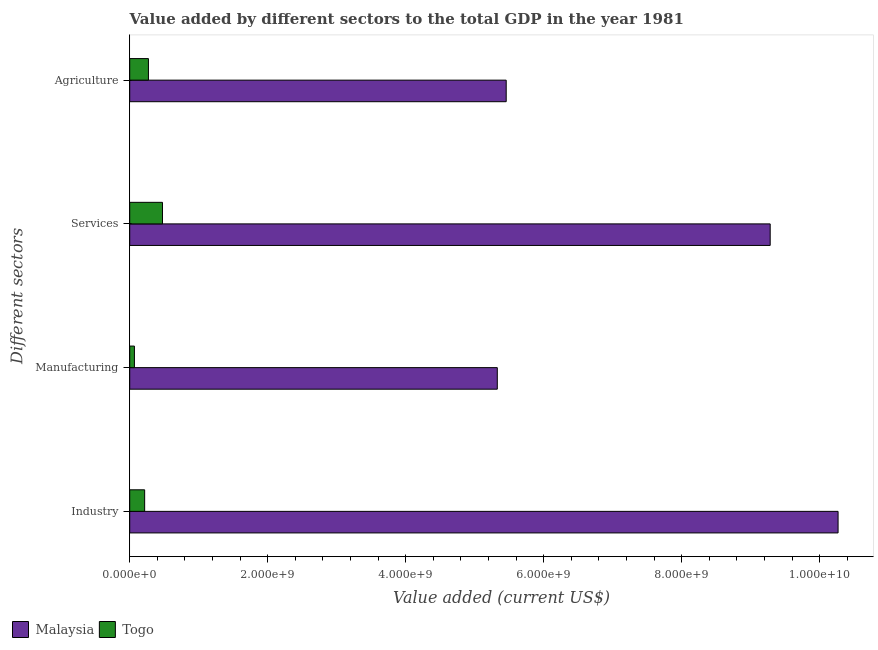How many groups of bars are there?
Give a very brief answer. 4. Are the number of bars on each tick of the Y-axis equal?
Offer a very short reply. Yes. How many bars are there on the 3rd tick from the top?
Your answer should be very brief. 2. How many bars are there on the 2nd tick from the bottom?
Offer a terse response. 2. What is the label of the 2nd group of bars from the top?
Ensure brevity in your answer.  Services. What is the value added by industrial sector in Togo?
Give a very brief answer. 2.16e+08. Across all countries, what is the maximum value added by services sector?
Ensure brevity in your answer.  9.28e+09. Across all countries, what is the minimum value added by industrial sector?
Ensure brevity in your answer.  2.16e+08. In which country was the value added by industrial sector maximum?
Give a very brief answer. Malaysia. In which country was the value added by industrial sector minimum?
Ensure brevity in your answer.  Togo. What is the total value added by services sector in the graph?
Offer a very short reply. 9.76e+09. What is the difference between the value added by manufacturing sector in Togo and that in Malaysia?
Provide a short and direct response. -5.26e+09. What is the difference between the value added by services sector in Malaysia and the value added by industrial sector in Togo?
Give a very brief answer. 9.07e+09. What is the average value added by agricultural sector per country?
Your answer should be very brief. 2.86e+09. What is the difference between the value added by agricultural sector and value added by industrial sector in Togo?
Provide a short and direct response. 5.48e+07. What is the ratio of the value added by industrial sector in Malaysia to that in Togo?
Keep it short and to the point. 47.44. What is the difference between the highest and the second highest value added by agricultural sector?
Give a very brief answer. 5.19e+09. What is the difference between the highest and the lowest value added by industrial sector?
Make the answer very short. 1.00e+1. In how many countries, is the value added by agricultural sector greater than the average value added by agricultural sector taken over all countries?
Your answer should be compact. 1. Is the sum of the value added by services sector in Togo and Malaysia greater than the maximum value added by industrial sector across all countries?
Your response must be concise. No. What does the 1st bar from the top in Manufacturing represents?
Your answer should be compact. Togo. What does the 1st bar from the bottom in Services represents?
Keep it short and to the point. Malaysia. How many countries are there in the graph?
Offer a terse response. 2. What is the difference between two consecutive major ticks on the X-axis?
Your answer should be compact. 2.00e+09. Does the graph contain any zero values?
Your response must be concise. No. Where does the legend appear in the graph?
Provide a short and direct response. Bottom left. How are the legend labels stacked?
Offer a terse response. Horizontal. What is the title of the graph?
Provide a succinct answer. Value added by different sectors to the total GDP in the year 1981. What is the label or title of the X-axis?
Make the answer very short. Value added (current US$). What is the label or title of the Y-axis?
Ensure brevity in your answer.  Different sectors. What is the Value added (current US$) of Malaysia in Industry?
Offer a very short reply. 1.03e+1. What is the Value added (current US$) of Togo in Industry?
Your response must be concise. 2.16e+08. What is the Value added (current US$) in Malaysia in Manufacturing?
Provide a short and direct response. 5.33e+09. What is the Value added (current US$) in Togo in Manufacturing?
Your answer should be very brief. 6.81e+07. What is the Value added (current US$) in Malaysia in Services?
Make the answer very short. 9.28e+09. What is the Value added (current US$) in Togo in Services?
Offer a terse response. 4.75e+08. What is the Value added (current US$) of Malaysia in Agriculture?
Make the answer very short. 5.46e+09. What is the Value added (current US$) in Togo in Agriculture?
Ensure brevity in your answer.  2.71e+08. Across all Different sectors, what is the maximum Value added (current US$) in Malaysia?
Give a very brief answer. 1.03e+1. Across all Different sectors, what is the maximum Value added (current US$) in Togo?
Provide a short and direct response. 4.75e+08. Across all Different sectors, what is the minimum Value added (current US$) in Malaysia?
Keep it short and to the point. 5.33e+09. Across all Different sectors, what is the minimum Value added (current US$) in Togo?
Offer a terse response. 6.81e+07. What is the total Value added (current US$) of Malaysia in the graph?
Offer a very short reply. 3.03e+1. What is the total Value added (current US$) in Togo in the graph?
Your answer should be compact. 1.03e+09. What is the difference between the Value added (current US$) in Malaysia in Industry and that in Manufacturing?
Make the answer very short. 4.94e+09. What is the difference between the Value added (current US$) of Togo in Industry and that in Manufacturing?
Provide a succinct answer. 1.48e+08. What is the difference between the Value added (current US$) of Malaysia in Industry and that in Services?
Provide a short and direct response. 9.84e+08. What is the difference between the Value added (current US$) of Togo in Industry and that in Services?
Your response must be concise. -2.58e+08. What is the difference between the Value added (current US$) of Malaysia in Industry and that in Agriculture?
Keep it short and to the point. 4.81e+09. What is the difference between the Value added (current US$) of Togo in Industry and that in Agriculture?
Keep it short and to the point. -5.48e+07. What is the difference between the Value added (current US$) of Malaysia in Manufacturing and that in Services?
Provide a short and direct response. -3.96e+09. What is the difference between the Value added (current US$) of Togo in Manufacturing and that in Services?
Offer a terse response. -4.07e+08. What is the difference between the Value added (current US$) in Malaysia in Manufacturing and that in Agriculture?
Provide a succinct answer. -1.29e+08. What is the difference between the Value added (current US$) of Togo in Manufacturing and that in Agriculture?
Provide a succinct answer. -2.03e+08. What is the difference between the Value added (current US$) of Malaysia in Services and that in Agriculture?
Keep it short and to the point. 3.83e+09. What is the difference between the Value added (current US$) in Togo in Services and that in Agriculture?
Make the answer very short. 2.04e+08. What is the difference between the Value added (current US$) in Malaysia in Industry and the Value added (current US$) in Togo in Manufacturing?
Ensure brevity in your answer.  1.02e+1. What is the difference between the Value added (current US$) in Malaysia in Industry and the Value added (current US$) in Togo in Services?
Provide a short and direct response. 9.79e+09. What is the difference between the Value added (current US$) in Malaysia in Industry and the Value added (current US$) in Togo in Agriculture?
Your answer should be very brief. 9.99e+09. What is the difference between the Value added (current US$) in Malaysia in Manufacturing and the Value added (current US$) in Togo in Services?
Your answer should be very brief. 4.85e+09. What is the difference between the Value added (current US$) of Malaysia in Manufacturing and the Value added (current US$) of Togo in Agriculture?
Give a very brief answer. 5.06e+09. What is the difference between the Value added (current US$) of Malaysia in Services and the Value added (current US$) of Togo in Agriculture?
Offer a terse response. 9.01e+09. What is the average Value added (current US$) in Malaysia per Different sectors?
Your answer should be compact. 7.58e+09. What is the average Value added (current US$) in Togo per Different sectors?
Your response must be concise. 2.58e+08. What is the difference between the Value added (current US$) of Malaysia and Value added (current US$) of Togo in Industry?
Offer a terse response. 1.00e+1. What is the difference between the Value added (current US$) in Malaysia and Value added (current US$) in Togo in Manufacturing?
Provide a succinct answer. 5.26e+09. What is the difference between the Value added (current US$) in Malaysia and Value added (current US$) in Togo in Services?
Give a very brief answer. 8.81e+09. What is the difference between the Value added (current US$) of Malaysia and Value added (current US$) of Togo in Agriculture?
Keep it short and to the point. 5.19e+09. What is the ratio of the Value added (current US$) of Malaysia in Industry to that in Manufacturing?
Keep it short and to the point. 1.93. What is the ratio of the Value added (current US$) of Togo in Industry to that in Manufacturing?
Provide a short and direct response. 3.18. What is the ratio of the Value added (current US$) in Malaysia in Industry to that in Services?
Offer a very short reply. 1.11. What is the ratio of the Value added (current US$) of Togo in Industry to that in Services?
Offer a very short reply. 0.46. What is the ratio of the Value added (current US$) of Malaysia in Industry to that in Agriculture?
Your answer should be very brief. 1.88. What is the ratio of the Value added (current US$) of Togo in Industry to that in Agriculture?
Keep it short and to the point. 0.8. What is the ratio of the Value added (current US$) of Malaysia in Manufacturing to that in Services?
Give a very brief answer. 0.57. What is the ratio of the Value added (current US$) in Togo in Manufacturing to that in Services?
Your answer should be very brief. 0.14. What is the ratio of the Value added (current US$) of Malaysia in Manufacturing to that in Agriculture?
Provide a short and direct response. 0.98. What is the ratio of the Value added (current US$) in Togo in Manufacturing to that in Agriculture?
Your answer should be compact. 0.25. What is the ratio of the Value added (current US$) of Malaysia in Services to that in Agriculture?
Offer a terse response. 1.7. What is the ratio of the Value added (current US$) of Togo in Services to that in Agriculture?
Offer a terse response. 1.75. What is the difference between the highest and the second highest Value added (current US$) of Malaysia?
Keep it short and to the point. 9.84e+08. What is the difference between the highest and the second highest Value added (current US$) of Togo?
Your answer should be very brief. 2.04e+08. What is the difference between the highest and the lowest Value added (current US$) in Malaysia?
Your answer should be compact. 4.94e+09. What is the difference between the highest and the lowest Value added (current US$) of Togo?
Provide a short and direct response. 4.07e+08. 